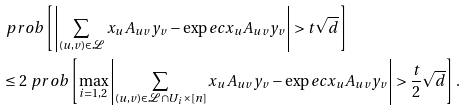<formula> <loc_0><loc_0><loc_500><loc_500>& \ p r o b \left [ \left | \sum _ { ( u , v ) \in \mathcal { L } } x _ { u } A _ { u v } y _ { v } - \exp e c x _ { u } A _ { u v } y _ { v } \right | > t \sqrt { d } \right ] \\ & \leq 2 \ p r o b \left [ \max _ { i = 1 , 2 } \left | \sum _ { ( u , v ) \in \mathcal { L } \cap U _ { i } \times [ n ] } x _ { u } A _ { u v } y _ { v } - \exp e c x _ { u } A _ { u v } y _ { v } \right | > \frac { t } { 2 } \sqrt { d } \right ] .</formula> 